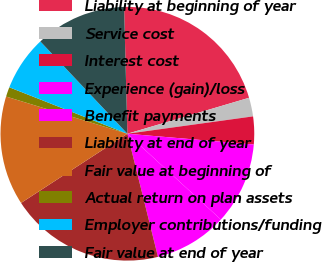Convert chart to OTSL. <chart><loc_0><loc_0><loc_500><loc_500><pie_chart><fcel>Liability at beginning of year<fcel>Service cost<fcel>Interest cost<fcel>Experience (gain)/loss<fcel>Benefit payments<fcel>Liability at end of year<fcel>Fair value at beginning of<fcel>Actual return on plan assets<fcel>Employer contributions/funding<fcel>Fair value at end of year<nl><fcel>20.84%<fcel>2.39%<fcel>3.54%<fcel>10.46%<fcel>9.31%<fcel>19.69%<fcel>13.92%<fcel>1.23%<fcel>7.0%<fcel>11.62%<nl></chart> 